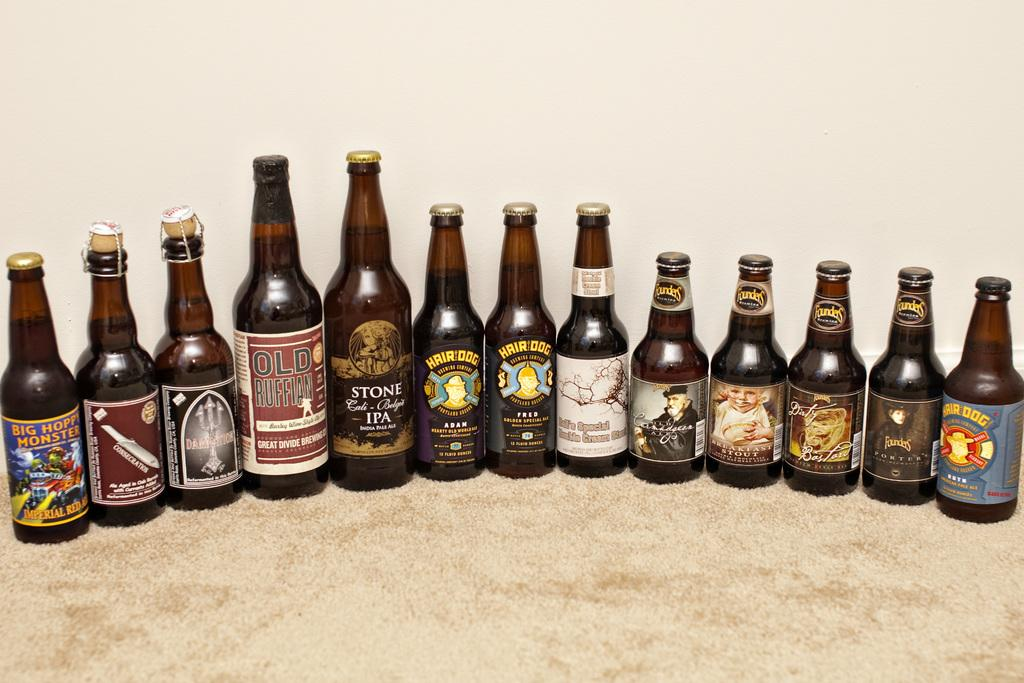<image>
Create a compact narrative representing the image presented. Several beers are lined up next to each other, one of them saying "OLD RUFFIAN." 